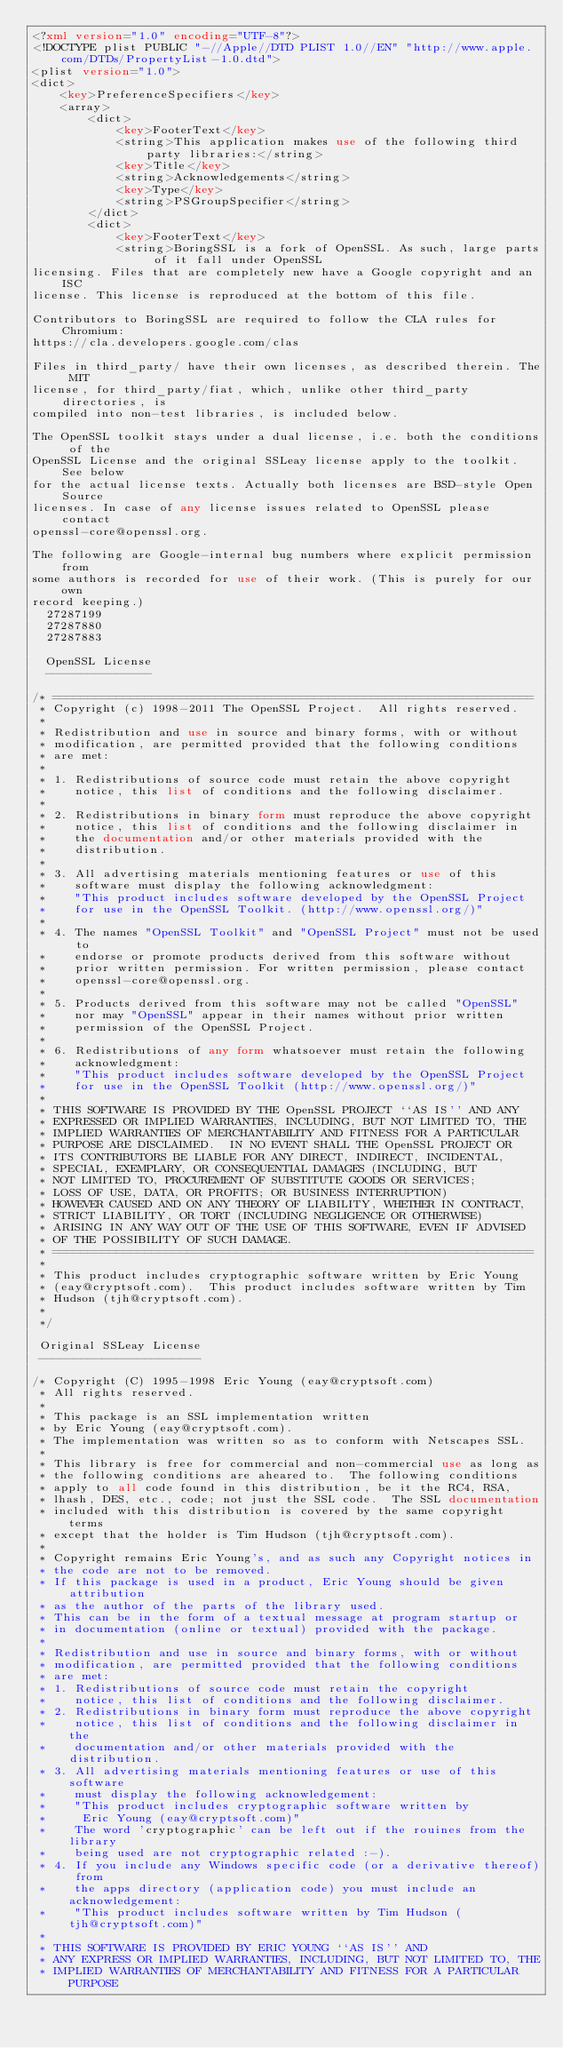Convert code to text. <code><loc_0><loc_0><loc_500><loc_500><_XML_><?xml version="1.0" encoding="UTF-8"?>
<!DOCTYPE plist PUBLIC "-//Apple//DTD PLIST 1.0//EN" "http://www.apple.com/DTDs/PropertyList-1.0.dtd">
<plist version="1.0">
<dict>
	<key>PreferenceSpecifiers</key>
	<array>
		<dict>
			<key>FooterText</key>
			<string>This application makes use of the following third party libraries:</string>
			<key>Title</key>
			<string>Acknowledgements</string>
			<key>Type</key>
			<string>PSGroupSpecifier</string>
		</dict>
		<dict>
			<key>FooterText</key>
			<string>BoringSSL is a fork of OpenSSL. As such, large parts of it fall under OpenSSL
licensing. Files that are completely new have a Google copyright and an ISC
license. This license is reproduced at the bottom of this file.

Contributors to BoringSSL are required to follow the CLA rules for Chromium:
https://cla.developers.google.com/clas

Files in third_party/ have their own licenses, as described therein. The MIT
license, for third_party/fiat, which, unlike other third_party directories, is
compiled into non-test libraries, is included below.

The OpenSSL toolkit stays under a dual license, i.e. both the conditions of the
OpenSSL License and the original SSLeay license apply to the toolkit. See below
for the actual license texts. Actually both licenses are BSD-style Open Source
licenses. In case of any license issues related to OpenSSL please contact
openssl-core@openssl.org.

The following are Google-internal bug numbers where explicit permission from
some authors is recorded for use of their work. (This is purely for our own
record keeping.)
  27287199
  27287880
  27287883

  OpenSSL License
  ---------------

/* ====================================================================
 * Copyright (c) 1998-2011 The OpenSSL Project.  All rights reserved.
 *
 * Redistribution and use in source and binary forms, with or without
 * modification, are permitted provided that the following conditions
 * are met:
 *
 * 1. Redistributions of source code must retain the above copyright
 *    notice, this list of conditions and the following disclaimer. 
 *
 * 2. Redistributions in binary form must reproduce the above copyright
 *    notice, this list of conditions and the following disclaimer in
 *    the documentation and/or other materials provided with the
 *    distribution.
 *
 * 3. All advertising materials mentioning features or use of this
 *    software must display the following acknowledgment:
 *    "This product includes software developed by the OpenSSL Project
 *    for use in the OpenSSL Toolkit. (http://www.openssl.org/)"
 *
 * 4. The names "OpenSSL Toolkit" and "OpenSSL Project" must not be used to
 *    endorse or promote products derived from this software without
 *    prior written permission. For written permission, please contact
 *    openssl-core@openssl.org.
 *
 * 5. Products derived from this software may not be called "OpenSSL"
 *    nor may "OpenSSL" appear in their names without prior written
 *    permission of the OpenSSL Project.
 *
 * 6. Redistributions of any form whatsoever must retain the following
 *    acknowledgment:
 *    "This product includes software developed by the OpenSSL Project
 *    for use in the OpenSSL Toolkit (http://www.openssl.org/)"
 *
 * THIS SOFTWARE IS PROVIDED BY THE OpenSSL PROJECT ``AS IS'' AND ANY
 * EXPRESSED OR IMPLIED WARRANTIES, INCLUDING, BUT NOT LIMITED TO, THE
 * IMPLIED WARRANTIES OF MERCHANTABILITY AND FITNESS FOR A PARTICULAR
 * PURPOSE ARE DISCLAIMED.  IN NO EVENT SHALL THE OpenSSL PROJECT OR
 * ITS CONTRIBUTORS BE LIABLE FOR ANY DIRECT, INDIRECT, INCIDENTAL,
 * SPECIAL, EXEMPLARY, OR CONSEQUENTIAL DAMAGES (INCLUDING, BUT
 * NOT LIMITED TO, PROCUREMENT OF SUBSTITUTE GOODS OR SERVICES;
 * LOSS OF USE, DATA, OR PROFITS; OR BUSINESS INTERRUPTION)
 * HOWEVER CAUSED AND ON ANY THEORY OF LIABILITY, WHETHER IN CONTRACT,
 * STRICT LIABILITY, OR TORT (INCLUDING NEGLIGENCE OR OTHERWISE)
 * ARISING IN ANY WAY OUT OF THE USE OF THIS SOFTWARE, EVEN IF ADVISED
 * OF THE POSSIBILITY OF SUCH DAMAGE.
 * ====================================================================
 *
 * This product includes cryptographic software written by Eric Young
 * (eay@cryptsoft.com).  This product includes software written by Tim
 * Hudson (tjh@cryptsoft.com).
 *
 */

 Original SSLeay License
 -----------------------

/* Copyright (C) 1995-1998 Eric Young (eay@cryptsoft.com)
 * All rights reserved.
 *
 * This package is an SSL implementation written
 * by Eric Young (eay@cryptsoft.com).
 * The implementation was written so as to conform with Netscapes SSL.
 * 
 * This library is free for commercial and non-commercial use as long as
 * the following conditions are aheared to.  The following conditions
 * apply to all code found in this distribution, be it the RC4, RSA,
 * lhash, DES, etc., code; not just the SSL code.  The SSL documentation
 * included with this distribution is covered by the same copyright terms
 * except that the holder is Tim Hudson (tjh@cryptsoft.com).
 * 
 * Copyright remains Eric Young's, and as such any Copyright notices in
 * the code are not to be removed.
 * If this package is used in a product, Eric Young should be given attribution
 * as the author of the parts of the library used.
 * This can be in the form of a textual message at program startup or
 * in documentation (online or textual) provided with the package.
 * 
 * Redistribution and use in source and binary forms, with or without
 * modification, are permitted provided that the following conditions
 * are met:
 * 1. Redistributions of source code must retain the copyright
 *    notice, this list of conditions and the following disclaimer.
 * 2. Redistributions in binary form must reproduce the above copyright
 *    notice, this list of conditions and the following disclaimer in the
 *    documentation and/or other materials provided with the distribution.
 * 3. All advertising materials mentioning features or use of this software
 *    must display the following acknowledgement:
 *    "This product includes cryptographic software written by
 *     Eric Young (eay@cryptsoft.com)"
 *    The word 'cryptographic' can be left out if the rouines from the library
 *    being used are not cryptographic related :-).
 * 4. If you include any Windows specific code (or a derivative thereof) from 
 *    the apps directory (application code) you must include an acknowledgement:
 *    "This product includes software written by Tim Hudson (tjh@cryptsoft.com)"
 * 
 * THIS SOFTWARE IS PROVIDED BY ERIC YOUNG ``AS IS'' AND
 * ANY EXPRESS OR IMPLIED WARRANTIES, INCLUDING, BUT NOT LIMITED TO, THE
 * IMPLIED WARRANTIES OF MERCHANTABILITY AND FITNESS FOR A PARTICULAR PURPOSE</code> 